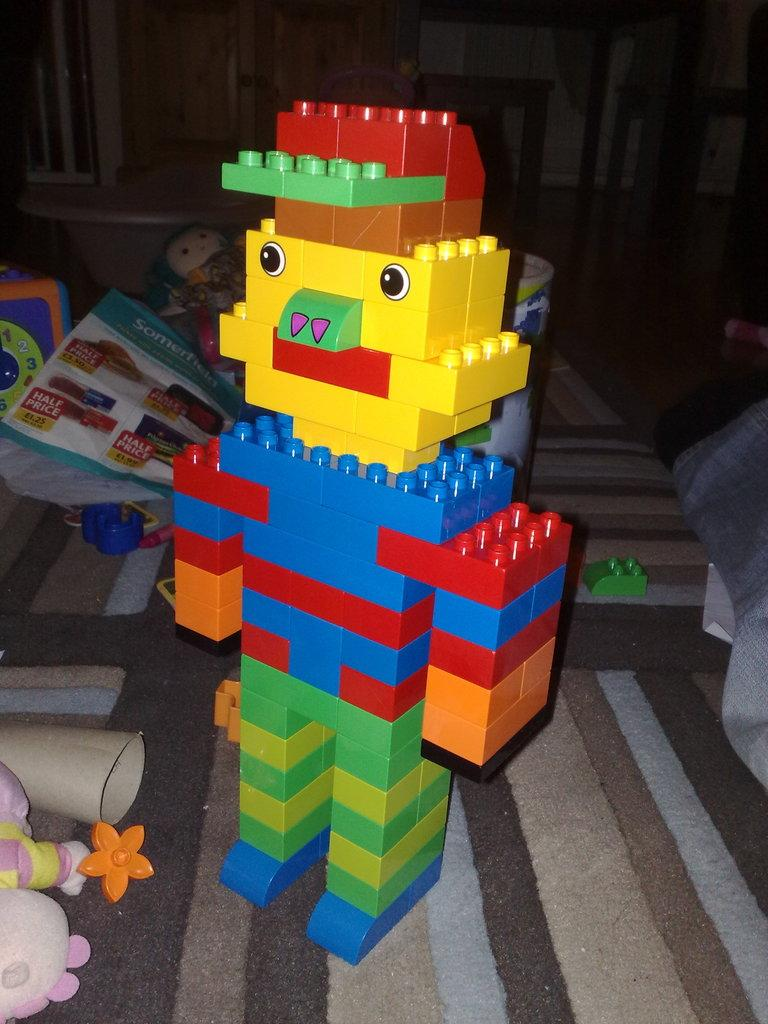What type of toy is visible in the image? There is a toy made with Lego in the image. Where is the Lego toy placed? The Lego toy is placed on a surface. What else can be seen in the image besides the Lego toy? There are papers and other toys in the image. What material is used to create the Lego toy? Lego blocks are present in the image, which are used to create the toy. How many geese are sitting on the cabbage in the image? There are no geese or cabbage present in the image. What type of ornament is hanging from the Lego toy in the image? There is no ornament hanging from the Lego toy in the image; only the Lego toy, papers, and other toys are present. 